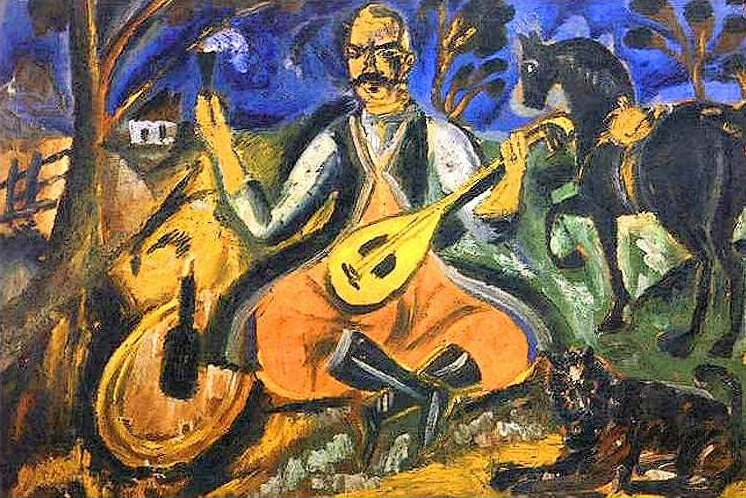What are the key elements in this picture? The painting is a vivid representation of a rural scene depicted in a post-impressionist style. Central to the image is a seated man dressed in a white shirt and orange pants, playing a lute with a contemplative expression, which suggests a moment of solitude or reflection. A black dog sits by him, emphasizing companionship and loyalty. The background features a rustic setting with a simple house and a cow, under a twilight sky. Artistically, the painting uses an expressive color palette and dynamic brushstrokes to convey a sense of tranquility and timelessness. 